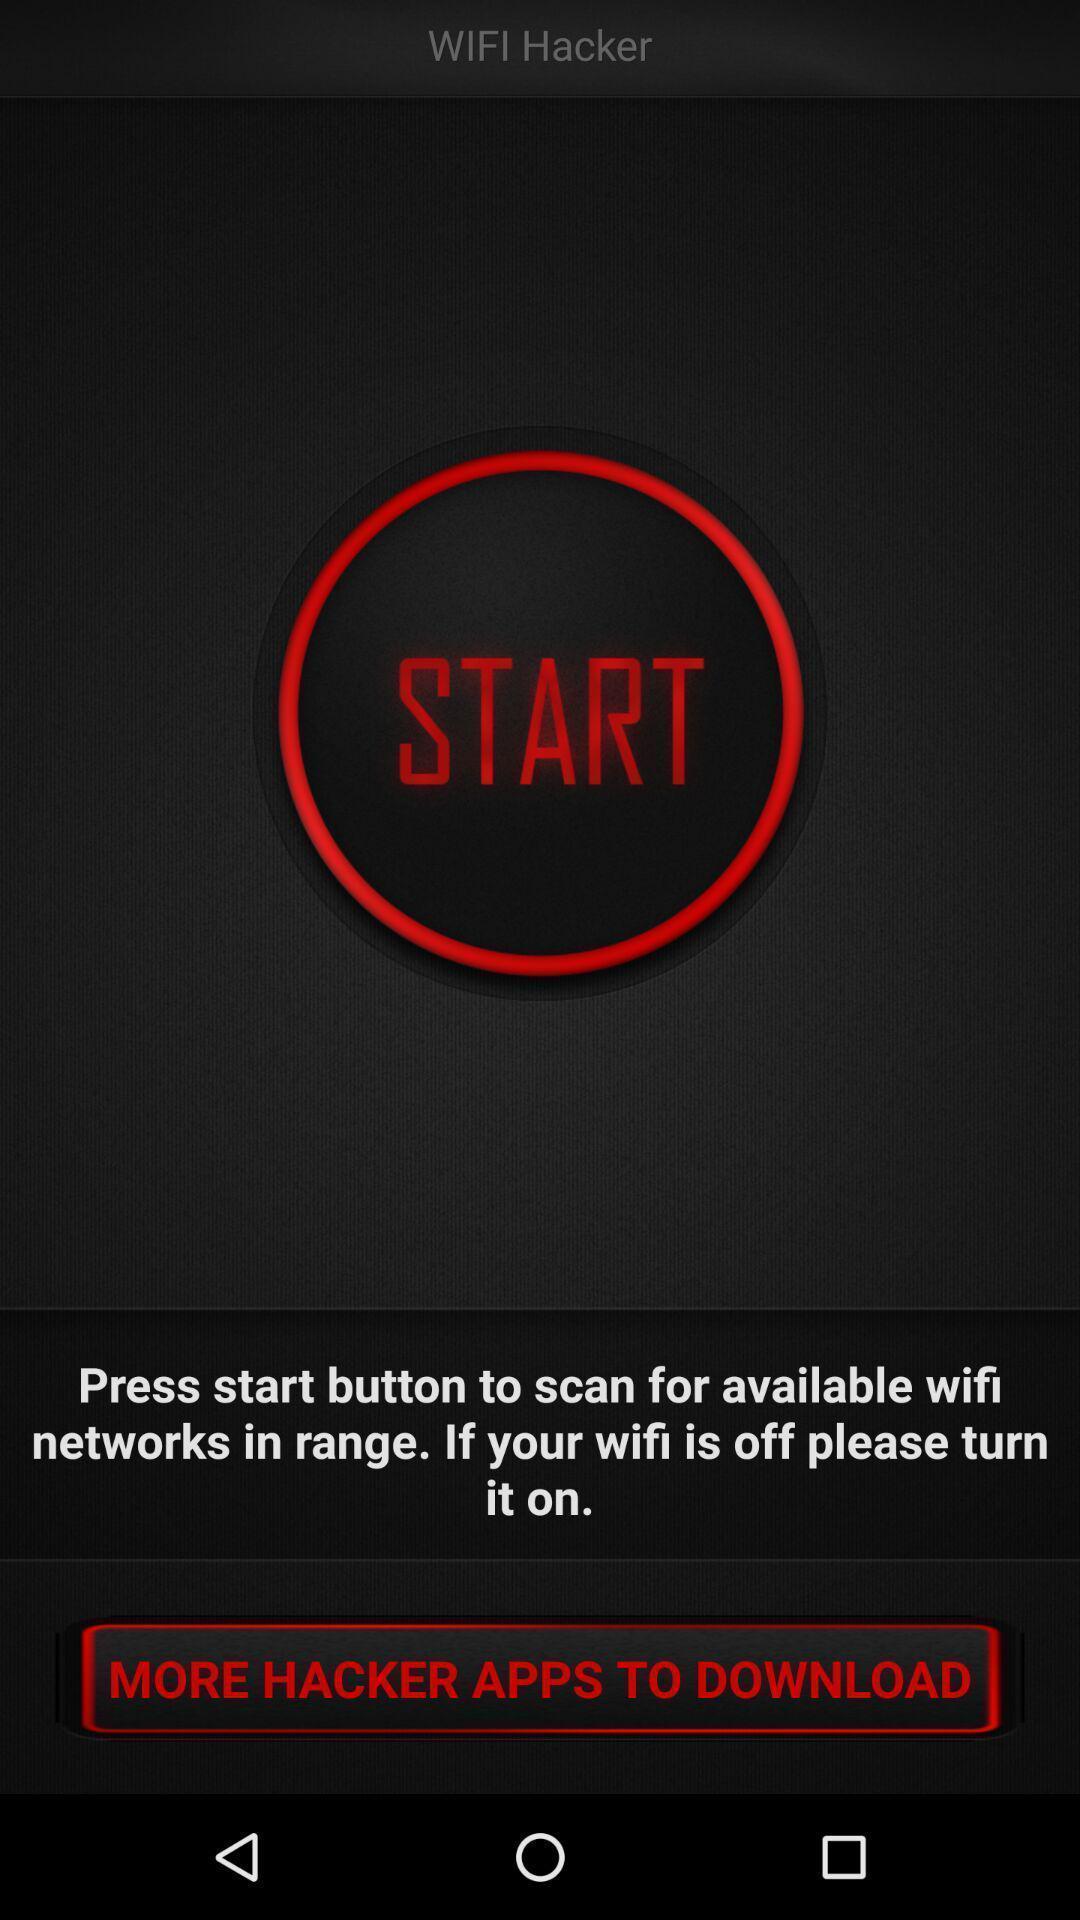What can you discern from this picture? Page showing start button and an option in hacking app. 